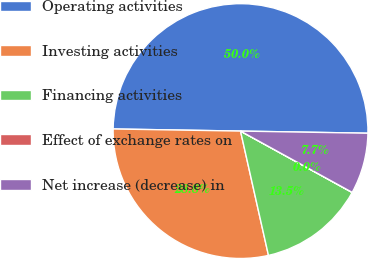Convert chart. <chart><loc_0><loc_0><loc_500><loc_500><pie_chart><fcel>Operating activities<fcel>Investing activities<fcel>Financing activities<fcel>Effect of exchange rates on<fcel>Net increase (decrease) in<nl><fcel>50.0%<fcel>28.78%<fcel>13.48%<fcel>0.01%<fcel>7.72%<nl></chart> 